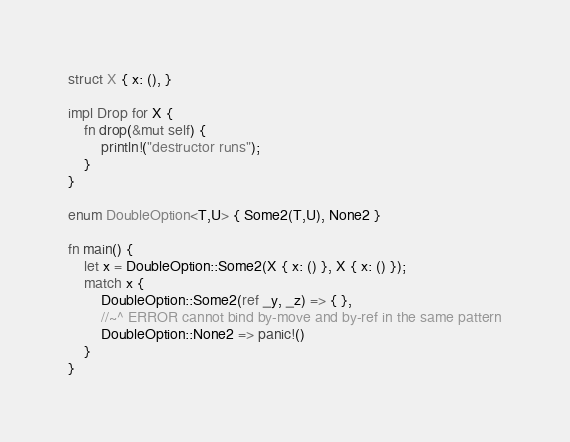Convert code to text. <code><loc_0><loc_0><loc_500><loc_500><_Rust_>struct X { x: (), }

impl Drop for X {
    fn drop(&mut self) {
        println!("destructor runs");
    }
}

enum DoubleOption<T,U> { Some2(T,U), None2 }

fn main() {
    let x = DoubleOption::Some2(X { x: () }, X { x: () });
    match x {
        DoubleOption::Some2(ref _y, _z) => { },
        //~^ ERROR cannot bind by-move and by-ref in the same pattern
        DoubleOption::None2 => panic!()
    }
}
</code> 